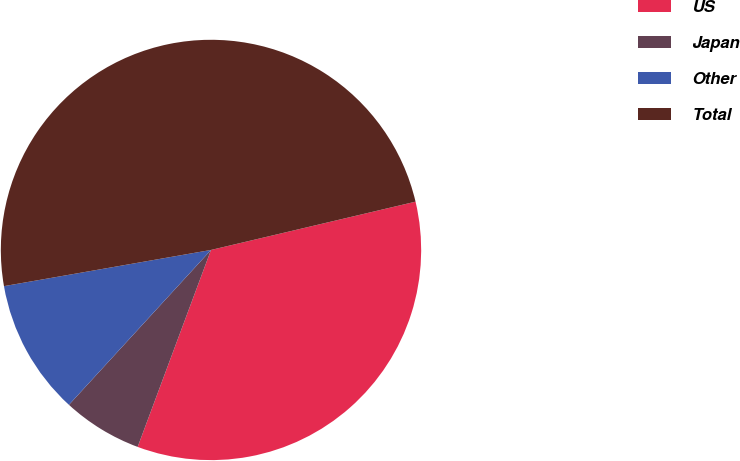Convert chart. <chart><loc_0><loc_0><loc_500><loc_500><pie_chart><fcel>US<fcel>Japan<fcel>Other<fcel>Total<nl><fcel>34.36%<fcel>6.14%<fcel>10.43%<fcel>49.06%<nl></chart> 